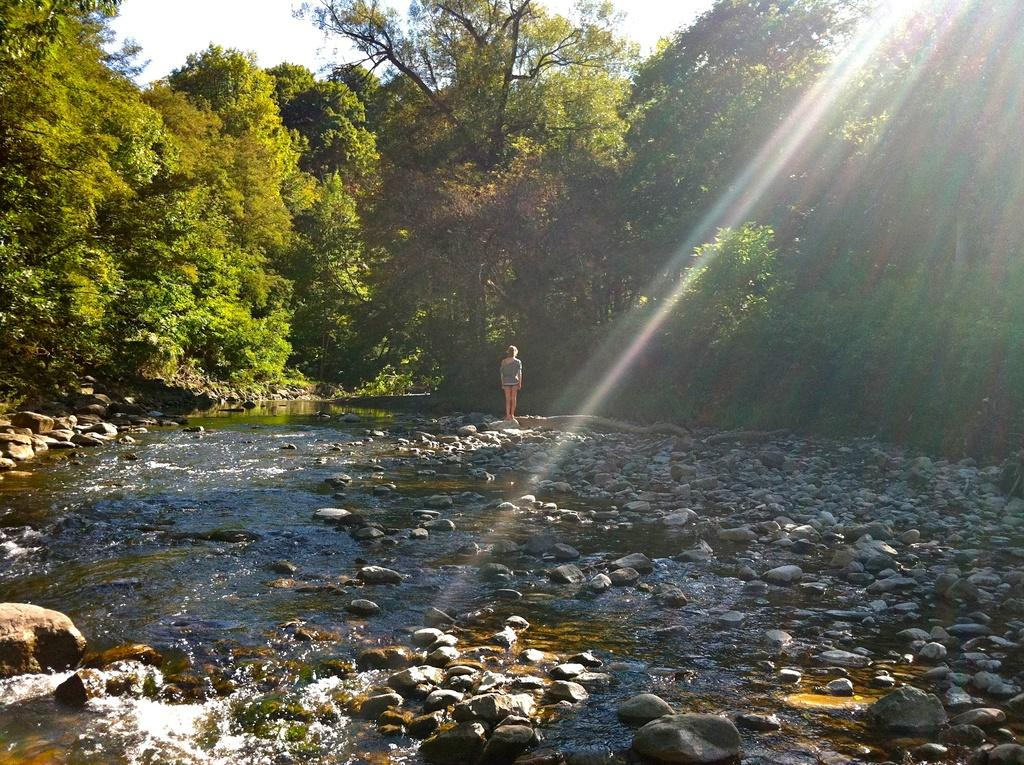What is the primary element in the image? There is water in the image. What other objects can be seen in the image? There are stones, a person standing, and many trees in the background. What can be seen in the sky in the image? Sky is visible in the image, and sun rays are also visible. What type of humor is being displayed by the giants in the image? There are no giants present in the image, so it is not possible to determine what type of humor they might be displaying. 